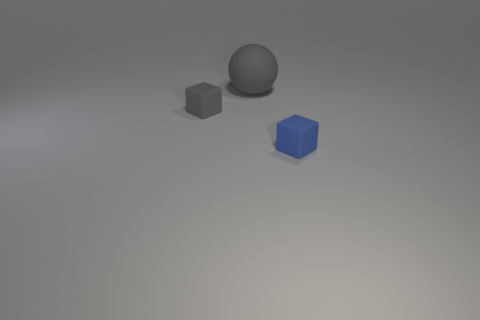Add 2 rubber objects. How many objects exist? 5 Subtract all gray blocks. How many blocks are left? 1 Subtract all balls. How many objects are left? 2 Subtract 2 blocks. How many blocks are left? 0 Subtract all brown blocks. Subtract all gray cylinders. How many blocks are left? 2 Subtract all green cylinders. How many gray cubes are left? 1 Subtract all big balls. Subtract all small green shiny cubes. How many objects are left? 2 Add 1 blue cubes. How many blue cubes are left? 2 Add 2 big cyan rubber things. How many big cyan rubber things exist? 2 Subtract 0 green spheres. How many objects are left? 3 